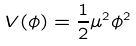Convert formula to latex. <formula><loc_0><loc_0><loc_500><loc_500>V ( \phi ) = { \frac { 1 } { 2 } } \mu ^ { 2 } \phi ^ { 2 }</formula> 